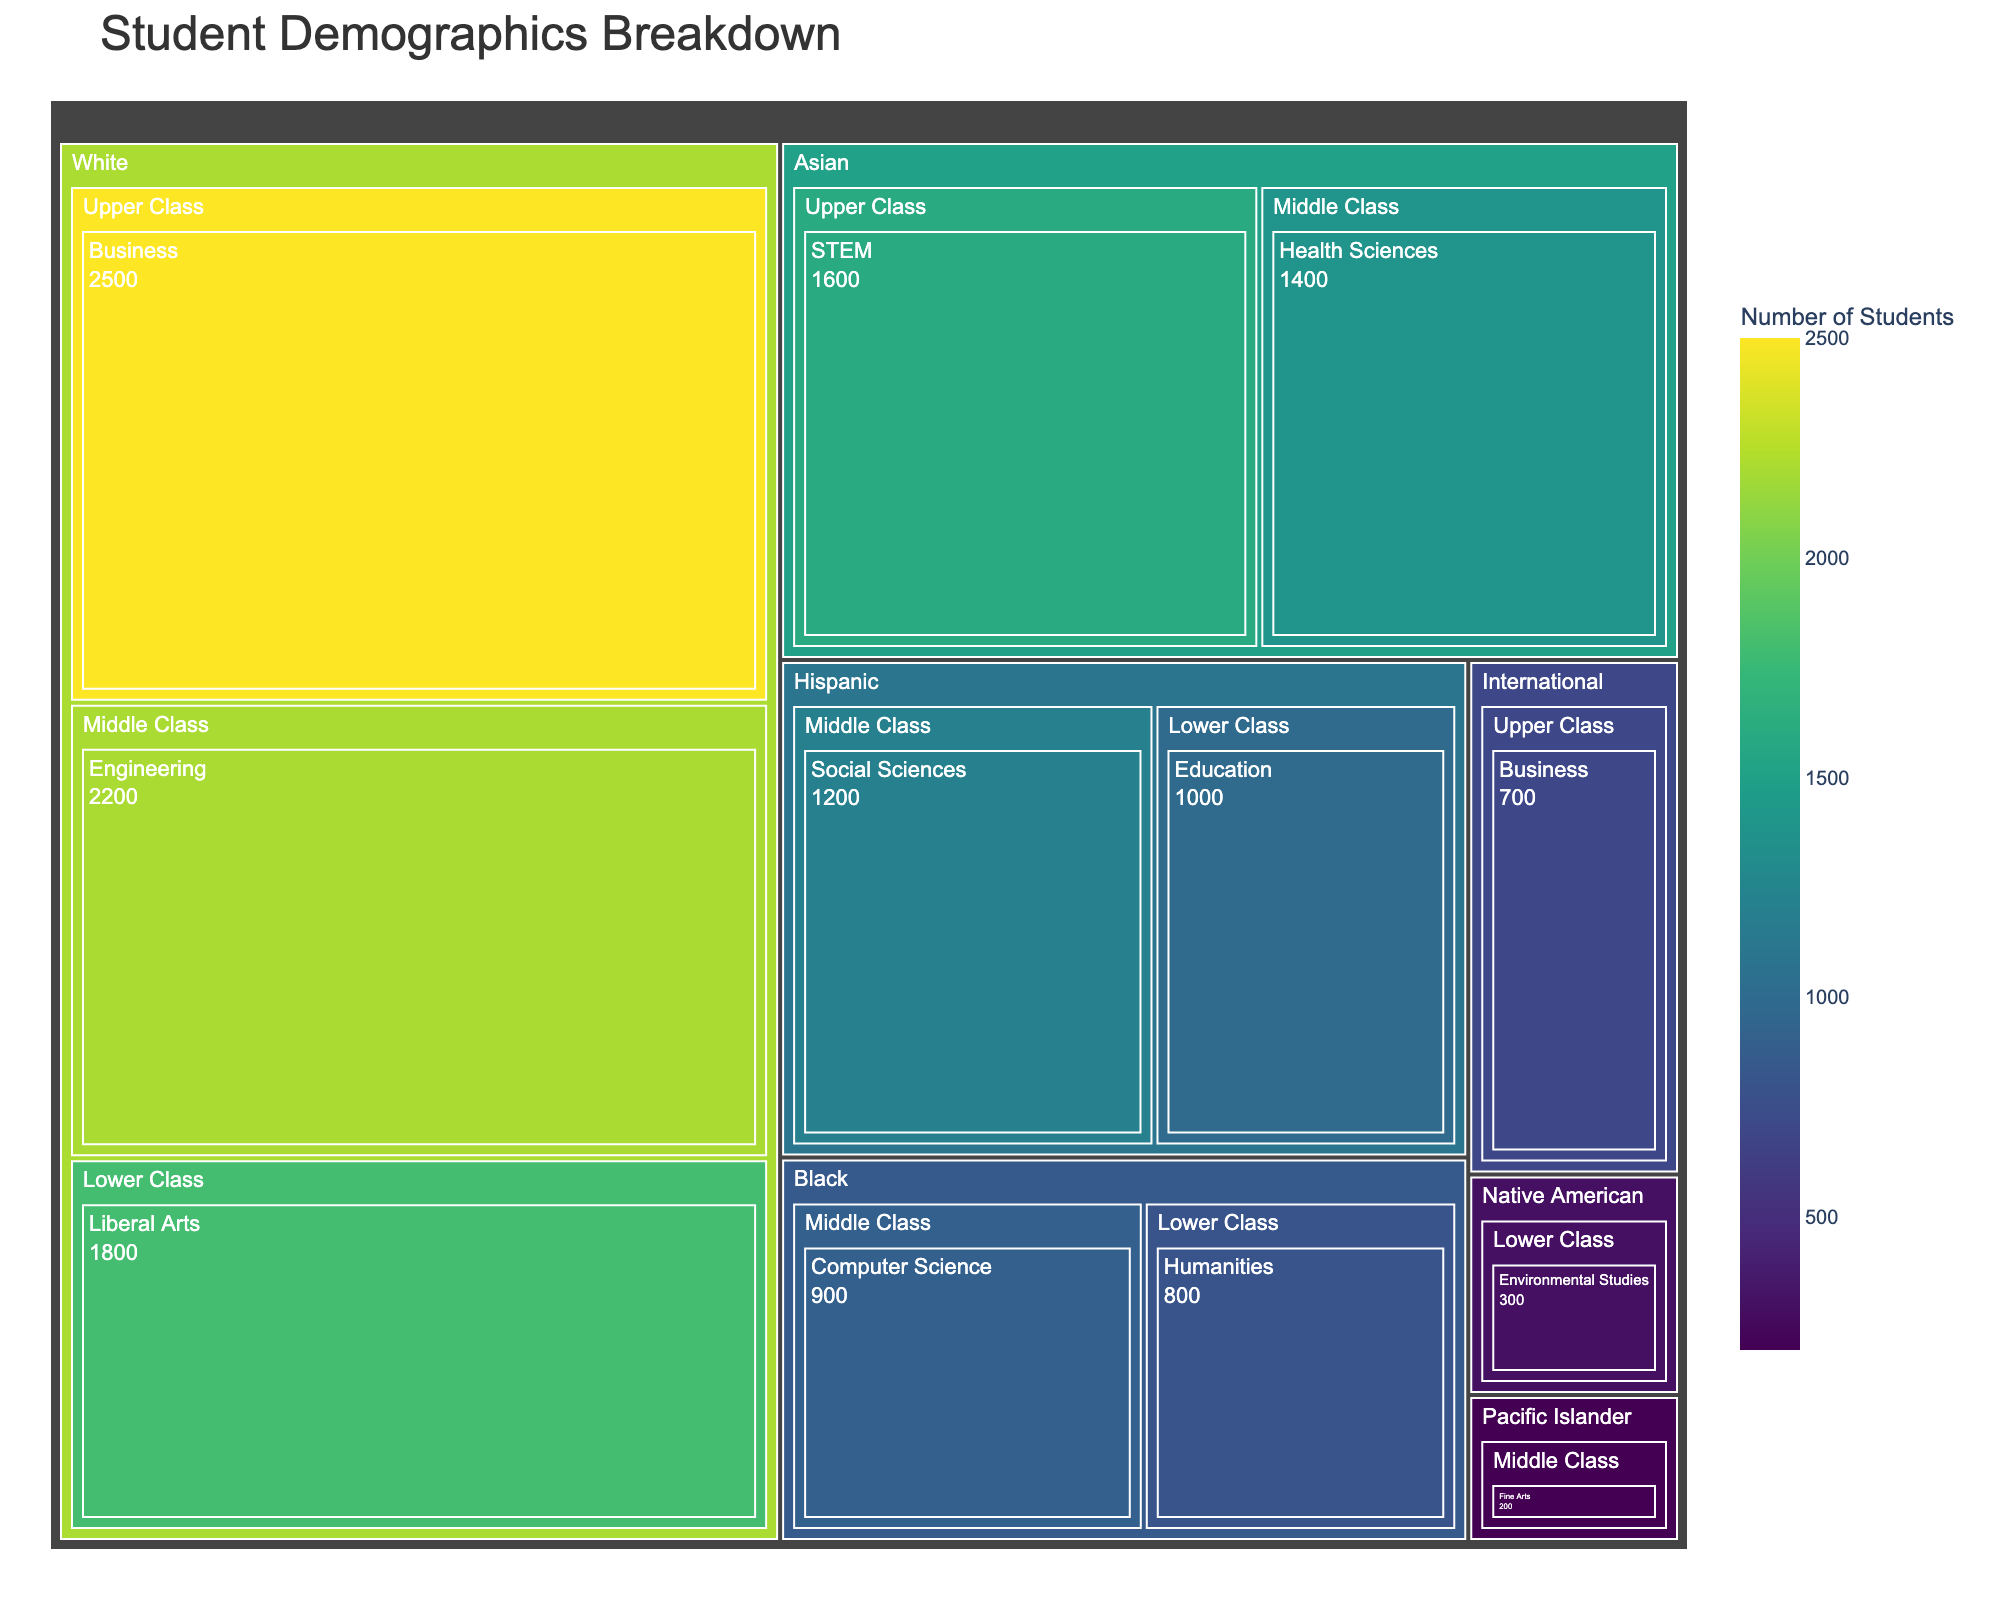What is the title of the treemap? The title is visible at the top of the treemap and sets the context for what is being displayed.
Answer: Student Demographics Breakdown Which ethnicity has the largest number of students in the Business field of study? From the treemap, we locate the different fields of study under various ethnicities. We see that "White" ethnicity has the largest number in Business.
Answer: White How many students are in the Middle Class socioeconomic status across all ethnicities? Sum the student numbers in the Middle Class categories across all ethnicities: Engineering (2200) + Health Sciences (1400) + Social Sciences (1200) + Computer Science (900) + Fine Arts (200) = 5900.
Answer: 5900 Which field of study has the least number of students and to which ethnic group and socioeconomic status does it belong? By examining the smallest segment within the treemap, we find that "Fine Arts" has the least number of students, belonging to the "Pacific Islander" ethnic group under "Middle Class" socioeconomic status.
Answer: Fine Arts, Pacific Islander, Middle Class Compare the number of Black students in Middle Class and Lower Class. Which group has more students and by how much? Black students are 900 in Middle Class and 800 in Lower Class. The difference is 900 - 800 = 100, so Middle Class has more students by 100.
Answer: Middle Class by 100 What percentage of Asian students are in the Upper Class socioeconomic status compared to the total number of Asian students? Total Asian students = 1600 (Upper Class) + 1400 (Middle Class) = 3000. The percentage in Upper Class is (1600 / 3000) * 100 ≈ 53.33%.
Answer: ≈ 53.33% Which socioeconomic status has the most diverse range of field of studies? By counting the number of different fields of study within each socioeconomic status, we see that Middle Class includes Engineering, Health Sciences, Social Sciences, Computer Science, and Fine Arts, which totals five fields.
Answer: Middle Class Is there any ethnic group that has students only in one socioeconomic status? By checking each ethnic group, we see "Native American" are only in Lower Class with Environmental Studies.
Answer: Native American How do the number of white students in Upper Class compare to the number of Asian students in Middle Class? White students in Upper Class (Business) are 2500, while Asian students in Middle Class (Health Sciences) are 1400. 2500 - 1400 = 1100, so White students in Upper Class exceed by 1100.
Answer: White in Upper Class exceed by 1100 